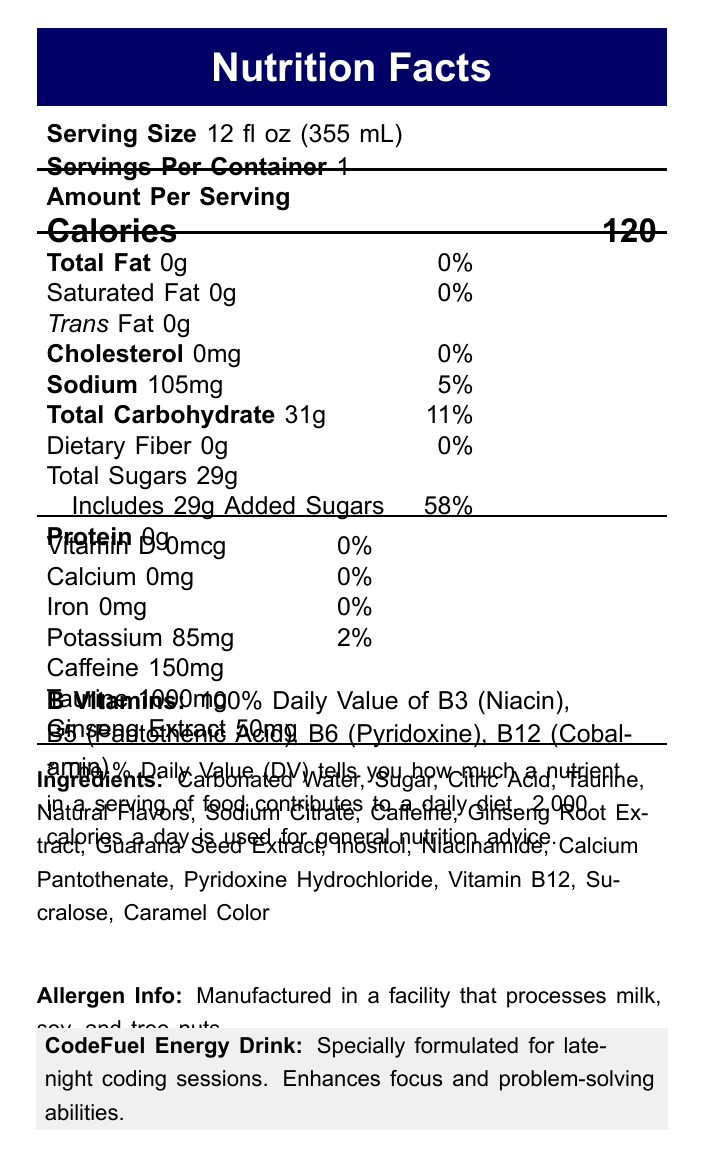what is the serving size of CodeFuel Energy Drink? The document states that the serving size for CodeFuel Energy Drink is 12 fl oz (355 mL).
Answer: 12 fl oz (355 mL) how many calories are in one serving of CodeFuel Energy Drink? According to the document, one serving of CodeFuel Energy Drink contains 120 calories.
Answer: 120 how much caffeine does one serving of CodeFuel Energy Drink contain? The document explicitly mentions that each serving of CodeFuel Energy Drink contains 150mg of caffeine.
Answer: 150mg what is the percentage of daily sodium intake per serving? The document lists sodium content as 105mg, which is 5% of the daily value.
Answer: 5% how many grams of total sugars are in one serving? The document states that there are 29 grams of total sugars in one serving of the energy drink.
Answer: 29g which of the following ingredients is NOT part of CodeFuel Energy Drink? A. Carbonated Water, B. Sugar, C. Taurine, and D. Ascorbic Acid. The document does not list Ascorbic Acid as one of the ingredients.
Answer: D. Ascorbic Acid what is the daily value percentage of Vitamin B6 in CodeFuel Energy Drink? The document indicates that Vitamin B6 (Pyridoxine) has a daily value of 100%.
Answer: 100% how many servings are per container? The document mentions that there is 1 serving per container.
Answer: 1 which of the following is a marketing claim for CodeFuel Energy Drink? A. No added sugars, B. Contains zero caffeine, C. Enhances focus and problem-solving abilities, D. Contains alcohol. The correct option, as stated in the document, is that it enhances focus and problem-solving abilities.
Answer: C. Enhances focus and problem-solving abilities are any allergens present in CodeFuel Energy Drink? The document states that it is manufactured in a facility that processes milk, soy, and tree nuts, but it does not mention any present allergens in the energy drink itself.
Answer: No can you drink more than two cans of CodeFuel Energy Drink per day? The document recommends not consuming more than 2 cans (24 fl oz) per day.
Answer: No describe the main idea of this document. This document is a comprehensive summary of the nutritional content, ingredients, and attributes of CodeFuel Energy Drink, targeted particularly to reinforce its benefits for software developers working late hours.
Answer: The document provides the Nutrition Facts label for CodeFuel Energy Drink, detailing its serving size, number of servings per container, calorie content, nutrient breakdown (including vitamins and minerals), ingredient list, allergen info, and various marketing claims. what is the manufacturing process of the CodeFuel Energy Drink? The document does not provide any details about the manufacturing process of the energy drink.
Answer: Not enough information 